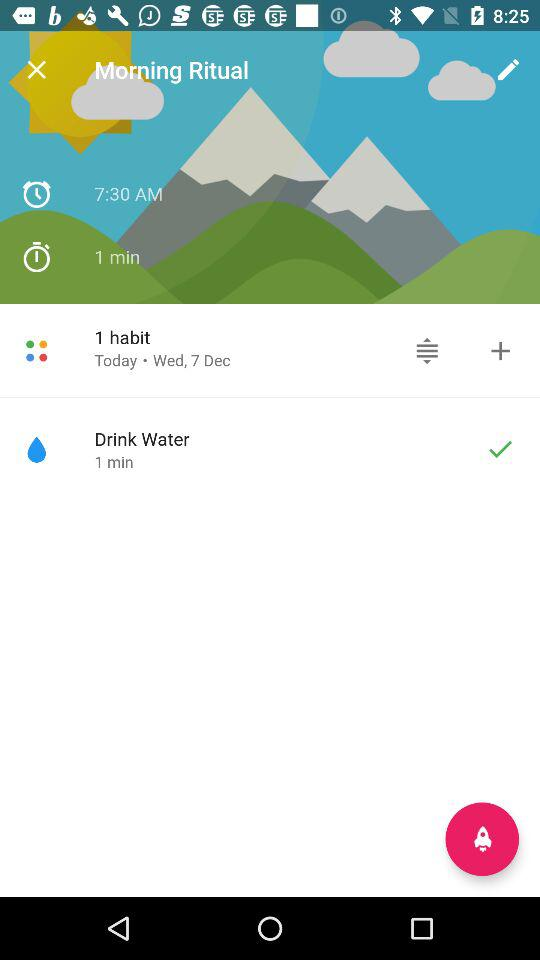What is the date of "1 habit"? The date is Wednesday, December 7. 